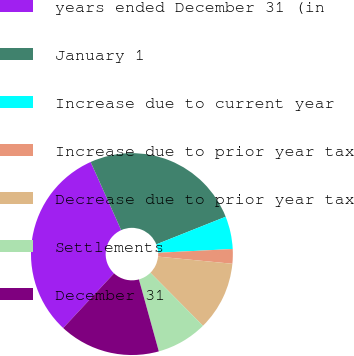<chart> <loc_0><loc_0><loc_500><loc_500><pie_chart><fcel>years ended December 31 (in<fcel>January 1<fcel>Increase due to current year<fcel>Increase due to prior year tax<fcel>Decrease due to prior year tax<fcel>Settlements<fcel>December 31<nl><fcel>31.38%<fcel>25.67%<fcel>5.23%<fcel>2.33%<fcel>11.04%<fcel>8.14%<fcel>16.21%<nl></chart> 